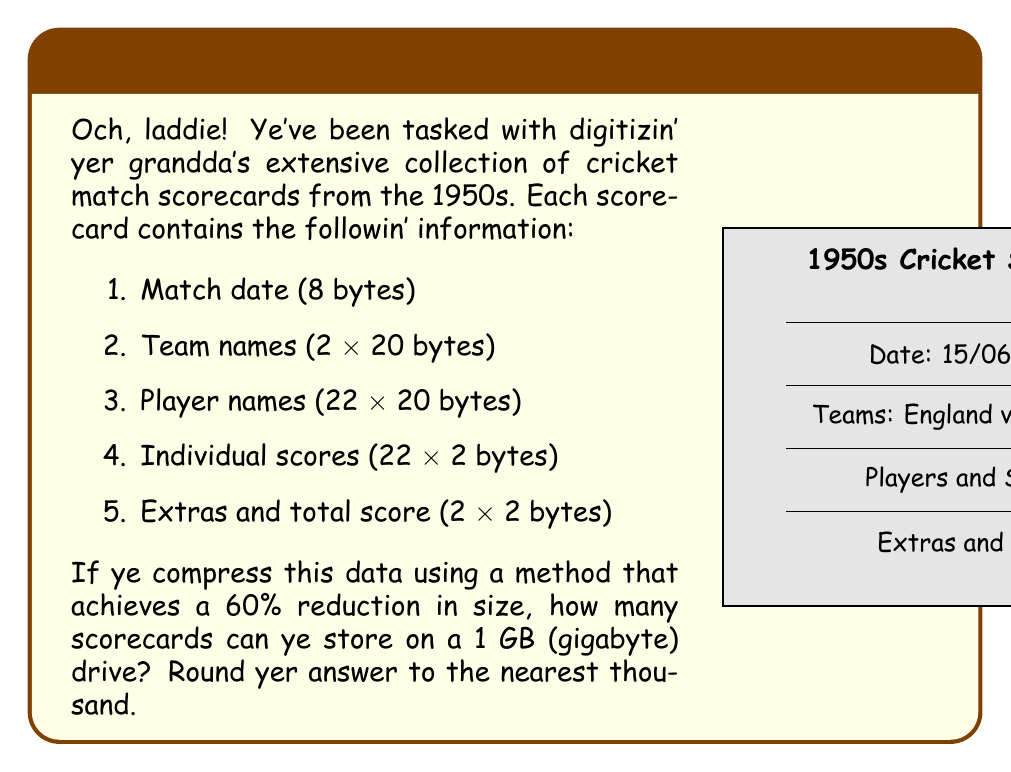Help me with this question. Let's approach this step-by-step:

1) First, calculate the total bytes per scorecard:
   $$8 + (2 \times 20) + (22 \times 20) + (22 \times 2) + (2 \times 2) = 508$$ bytes

2) Convert 1 GB to bytes:
   $$1 \text{ GB} = 1,000,000,000$$ bytes

3) Calculate the compressed size of each scorecard:
   $$508 \times (1 - 0.60) = 508 \times 0.40 = 203.2$$ bytes

4) Calculate the number of scorecards that can be stored:
   $$\frac{1,000,000,000}{203.2} \approx 4,921,259.84$$

5) Round to the nearest thousand:
   $$4,921,259.84 \approx 4,921,000$$

Therefore, approximately 4,921,000 compressed scorecards can be stored on a 1 GB drive.
Answer: 4,921,000 scorecards 